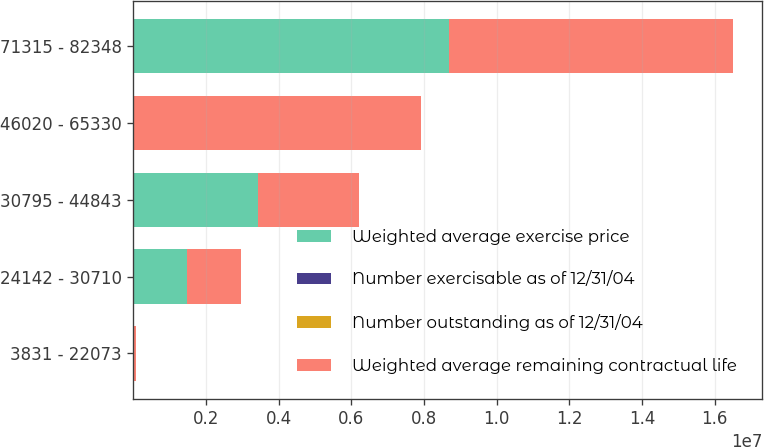<chart> <loc_0><loc_0><loc_500><loc_500><stacked_bar_chart><ecel><fcel>3831 - 22073<fcel>24142 - 30710<fcel>30795 - 44843<fcel>46020 - 65330<fcel>71315 - 82348<nl><fcel>Weighted average exercise price<fcel>32617<fcel>1.48155e+06<fcel>3.42552e+06<fcel>80.71<fcel>8.67626e+06<nl><fcel>Number exercisable as of 12/31/04<fcel>1.14<fcel>0.94<fcel>3.23<fcel>6.95<fcel>4.23<nl><fcel>Number outstanding as of 12/31/04<fcel>21.98<fcel>30.09<fcel>39.8<fcel>55.74<fcel>80.71<nl><fcel>Weighted average remaining contractual life<fcel>32617<fcel>1.48155e+06<fcel>2.7998e+06<fcel>7.91297e+06<fcel>7.81781e+06<nl></chart> 